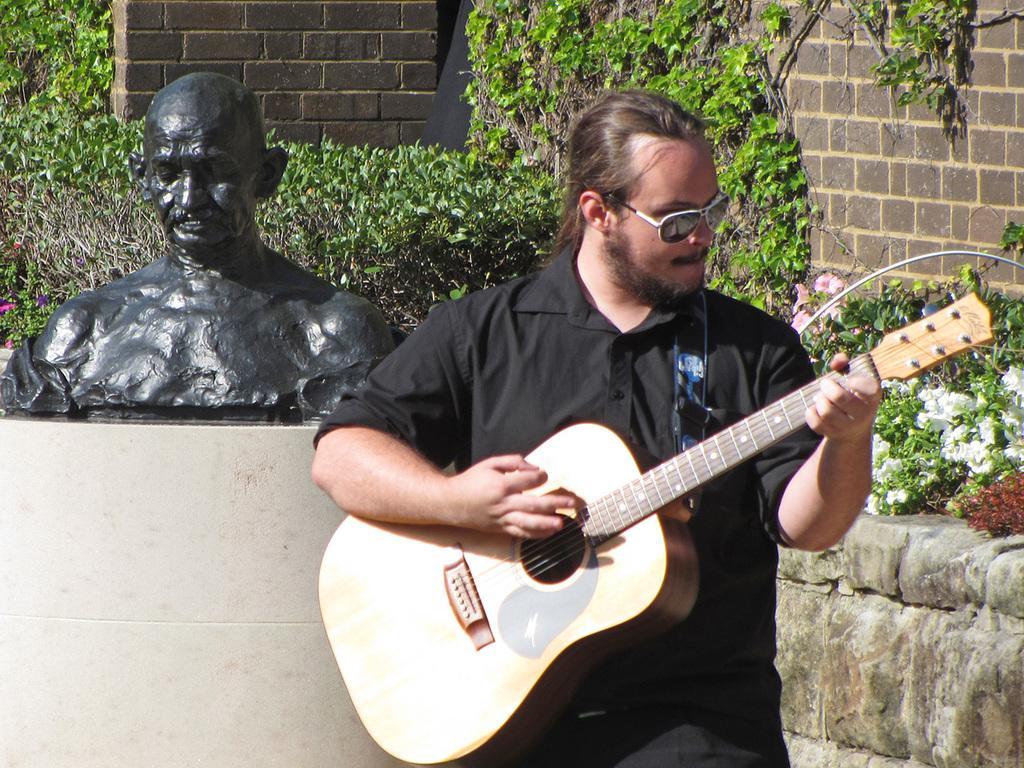How would you summarize this image in a sentence or two? In this picture we can see a man who is playing guitar. He has goggles. This is sculpture. On the background we can see a wall. And these are the plants. 